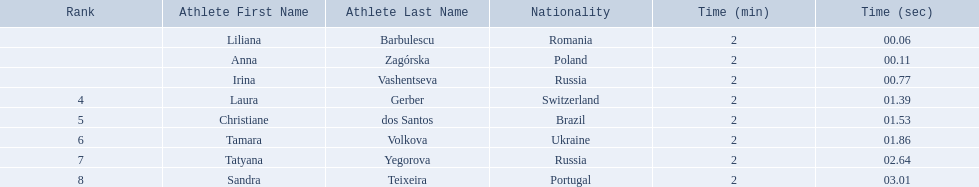Who are all of the athletes? Liliana Barbulescu, Anna Zagórska, Irina Vashentseva, Laura Gerber, Christiane dos Santos, Tamara Volkova, Tatyana Yegorova, Sandra Teixeira. What were their times in the heat? 2:00.06, 2:00.11, 2:00.77, 2:01.39, 2:01.53, 2:01.86, 2:02.64, 2:03.01. Of these, which is the top time? 2:00.06. Which athlete had this time? Liliana Barbulescu. 